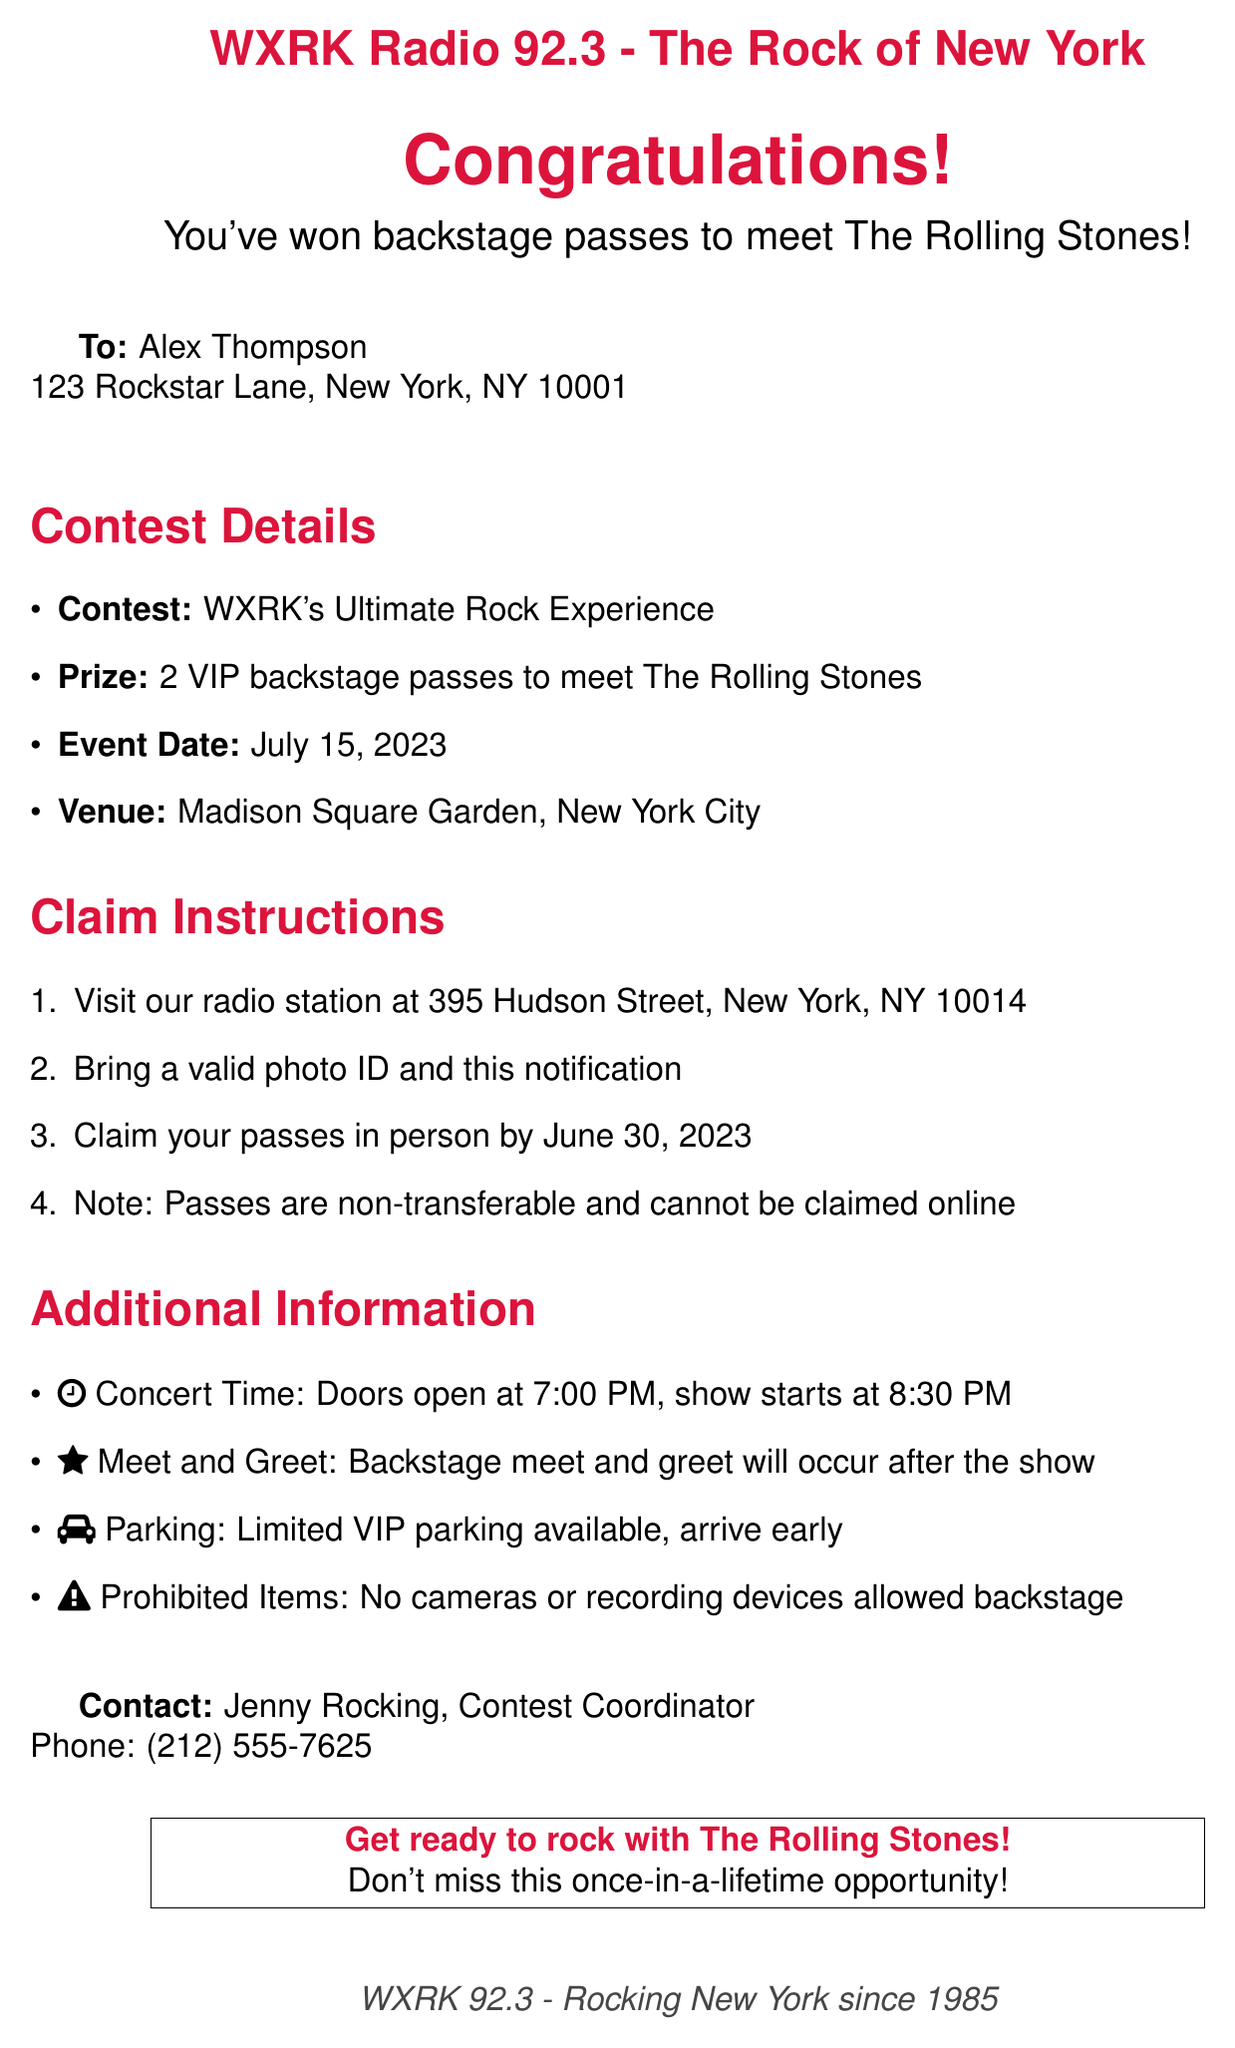what is the name of the contest? The contest is titled "WXRK's Ultimate Rock Experience" as specified in the document.
Answer: WXRK's Ultimate Rock Experience who is the winner of the contest? The winner is mentioned at the beginning of the document as Alex Thompson.
Answer: Alex Thompson what date do the passes need to be claimed by? The document states that passes must be claimed in person by June 30, 2023.
Answer: June 30, 2023 where will the event take place? The venue for the event is listed as Madison Square Garden, New York City in the contest details.
Answer: Madison Square Garden what time do the doors open for the concert? The document indicates that doors open at 7:00 PM before the concert starts.
Answer: 7:00 PM who can you contact for more information? The contact information provided in the document names Jenny Rocking as the Contest Coordinator.
Answer: Jenny Rocking are the passes transferable? The instructions explicitly state that passes are non-transferable.
Answer: Non-transferable what items are prohibited backstage? The document clearly mentions that no cameras or recording devices are allowed backstage.
Answer: Cameras or recording devices what is the prize for winning the contest? The prize is specified as 2 VIP backstage passes to meet The Rolling Stones in the prize details.
Answer: 2 VIP backstage passes to meet The Rolling Stones 